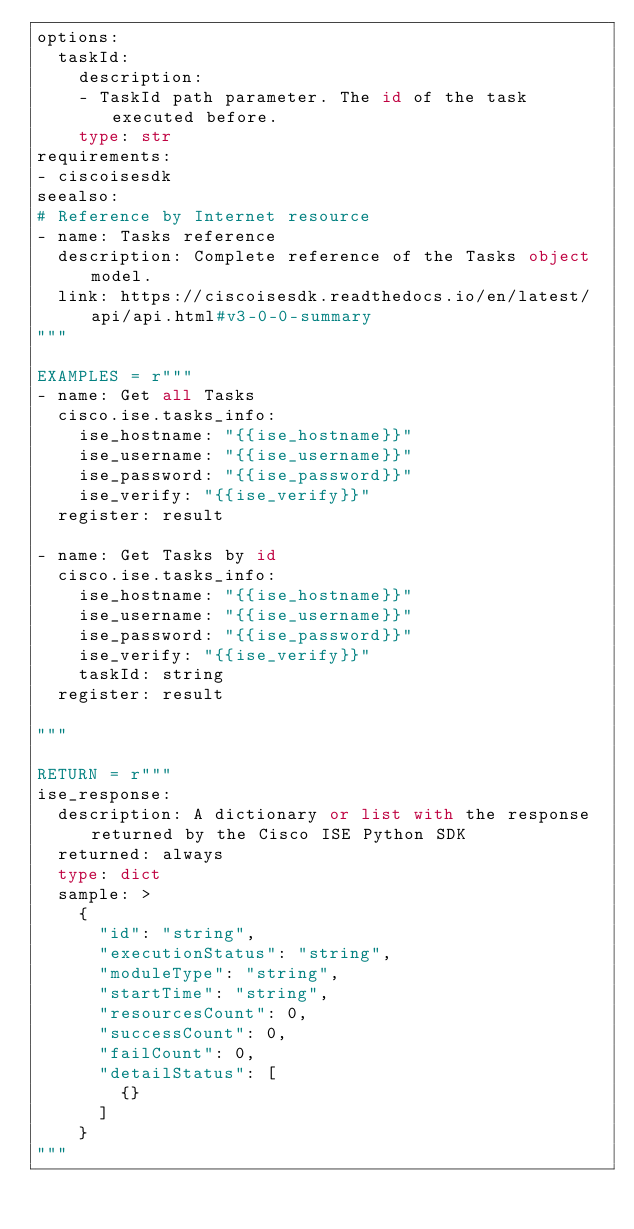<code> <loc_0><loc_0><loc_500><loc_500><_Python_>options:
  taskId:
    description:
    - TaskId path parameter. The id of the task executed before.
    type: str
requirements:
- ciscoisesdk
seealso:
# Reference by Internet resource
- name: Tasks reference
  description: Complete reference of the Tasks object model.
  link: https://ciscoisesdk.readthedocs.io/en/latest/api/api.html#v3-0-0-summary
"""

EXAMPLES = r"""
- name: Get all Tasks
  cisco.ise.tasks_info:
    ise_hostname: "{{ise_hostname}}"
    ise_username: "{{ise_username}}"
    ise_password: "{{ise_password}}"
    ise_verify: "{{ise_verify}}"
  register: result

- name: Get Tasks by id
  cisco.ise.tasks_info:
    ise_hostname: "{{ise_hostname}}"
    ise_username: "{{ise_username}}"
    ise_password: "{{ise_password}}"
    ise_verify: "{{ise_verify}}"
    taskId: string
  register: result

"""

RETURN = r"""
ise_response:
  description: A dictionary or list with the response returned by the Cisco ISE Python SDK
  returned: always
  type: dict
  sample: >
    {
      "id": "string",
      "executionStatus": "string",
      "moduleType": "string",
      "startTime": "string",
      "resourcesCount": 0,
      "successCount": 0,
      "failCount": 0,
      "detailStatus": [
        {}
      ]
    }
"""
</code> 